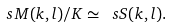<formula> <loc_0><loc_0><loc_500><loc_500>\ s M ( k , l ) / K \simeq \ s S ( k , l ) .</formula> 